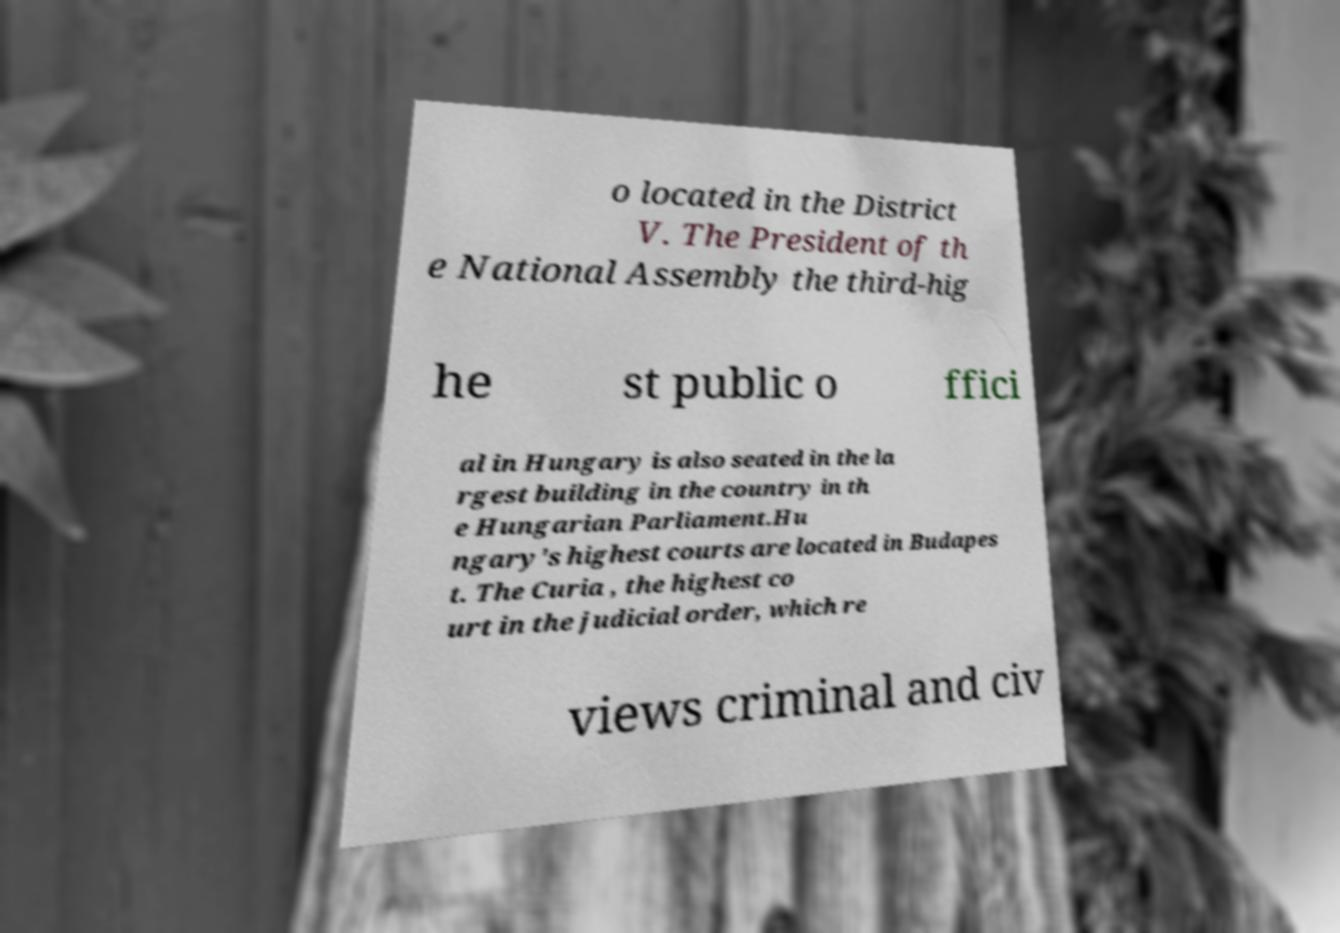Please read and relay the text visible in this image. What does it say? o located in the District V. The President of th e National Assembly the third-hig he st public o ffici al in Hungary is also seated in the la rgest building in the country in th e Hungarian Parliament.Hu ngary's highest courts are located in Budapes t. The Curia , the highest co urt in the judicial order, which re views criminal and civ 